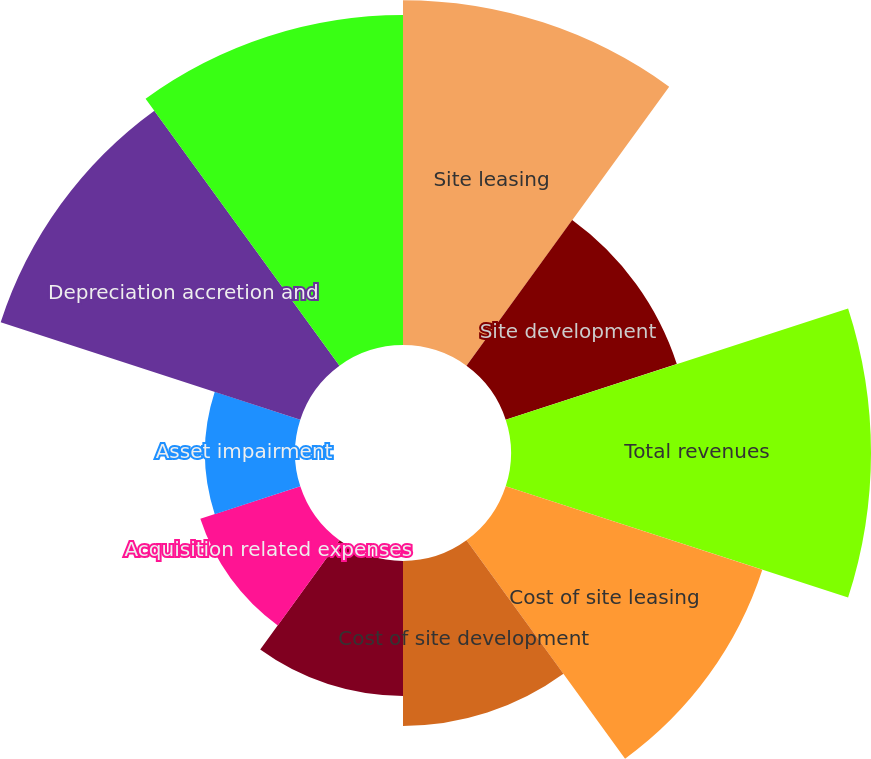<chart> <loc_0><loc_0><loc_500><loc_500><pie_chart><fcel>Site leasing<fcel>Site development<fcel>Total revenues<fcel>Cost of site leasing<fcel>Cost of site development<fcel>Selling general and<fcel>Acquisition related expenses<fcel>Asset impairment<fcel>Depreciation accretion and<fcel>Total operating expenses<nl><fcel>15.03%<fcel>7.84%<fcel>15.69%<fcel>11.76%<fcel>7.19%<fcel>5.88%<fcel>4.58%<fcel>3.92%<fcel>13.73%<fcel>14.38%<nl></chart> 